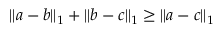Convert formula to latex. <formula><loc_0><loc_0><loc_500><loc_500>\| a - b \| _ { 1 } + \| b - c \| _ { 1 } \geq \| a - c \| _ { 1 }</formula> 